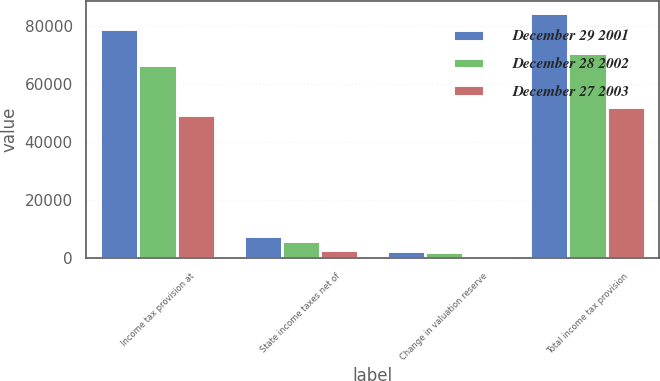Convert chart to OTSL. <chart><loc_0><loc_0><loc_500><loc_500><stacked_bar_chart><ecel><fcel>Income tax provision at<fcel>State income taxes net of<fcel>Change in valuation reserve<fcel>Total income tax provision<nl><fcel>December 29 2001<fcel>79020<fcel>7684<fcel>2326<fcel>84378<nl><fcel>December 28 2002<fcel>66652<fcel>5897<fcel>2039<fcel>70510<nl><fcel>December 27 2003<fcel>49122<fcel>2626<fcel>182<fcel>51930<nl></chart> 